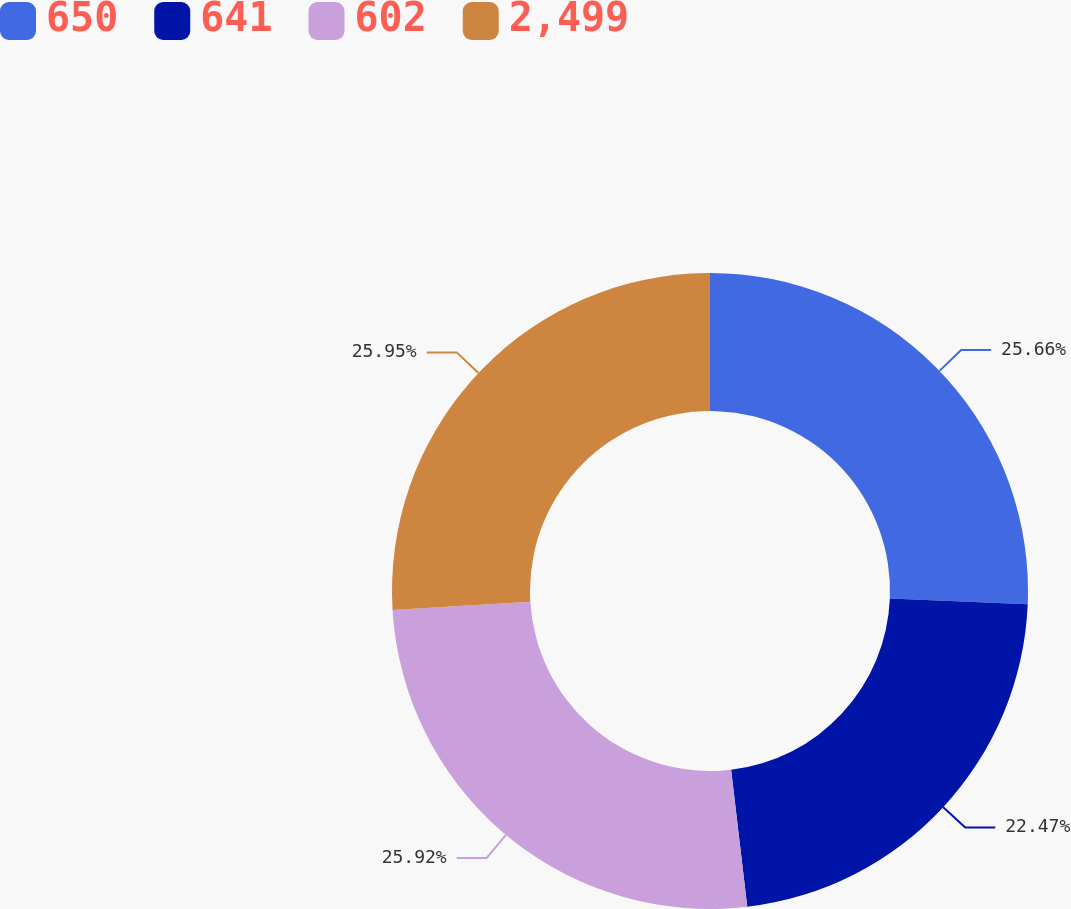Convert chart to OTSL. <chart><loc_0><loc_0><loc_500><loc_500><pie_chart><fcel>650<fcel>641<fcel>602<fcel>2,499<nl><fcel>25.66%<fcel>22.47%<fcel>25.92%<fcel>25.95%<nl></chart> 